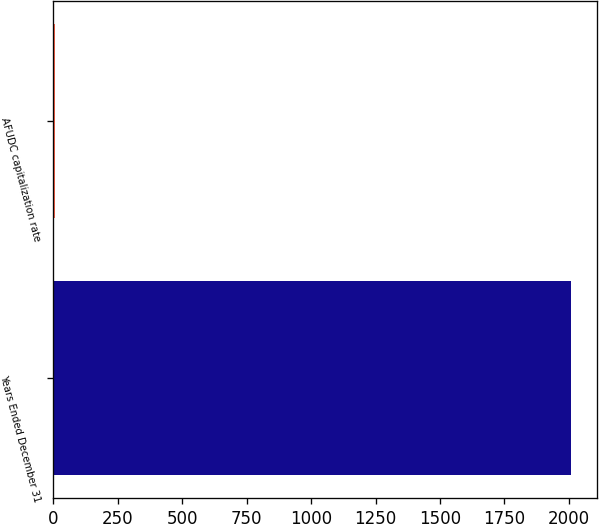Convert chart to OTSL. <chart><loc_0><loc_0><loc_500><loc_500><bar_chart><fcel>Years Ended December 31<fcel>AFUDC capitalization rate<nl><fcel>2009<fcel>7.6<nl></chart> 